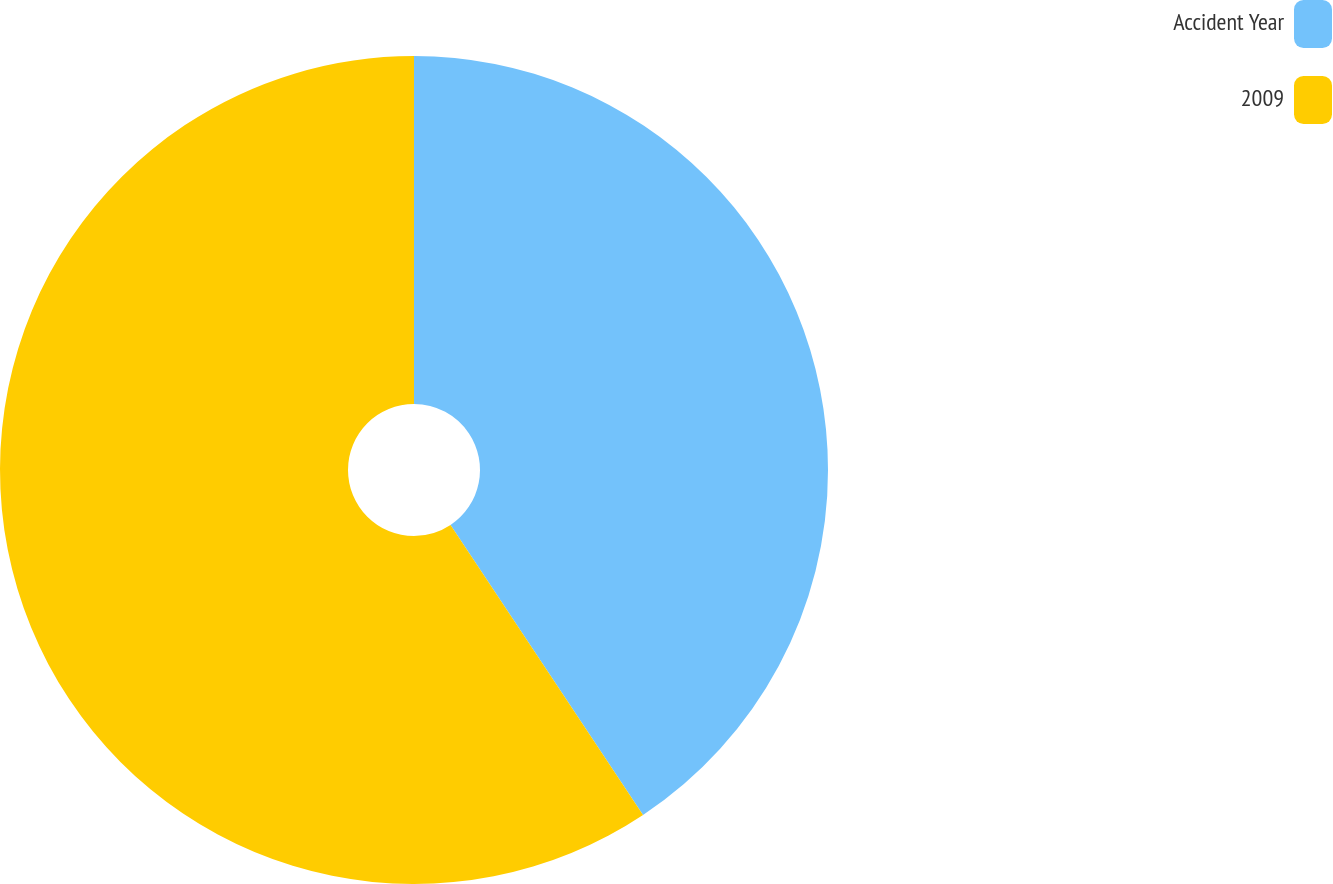Convert chart. <chart><loc_0><loc_0><loc_500><loc_500><pie_chart><fcel>Accident Year<fcel>2009<nl><fcel>40.67%<fcel>59.33%<nl></chart> 